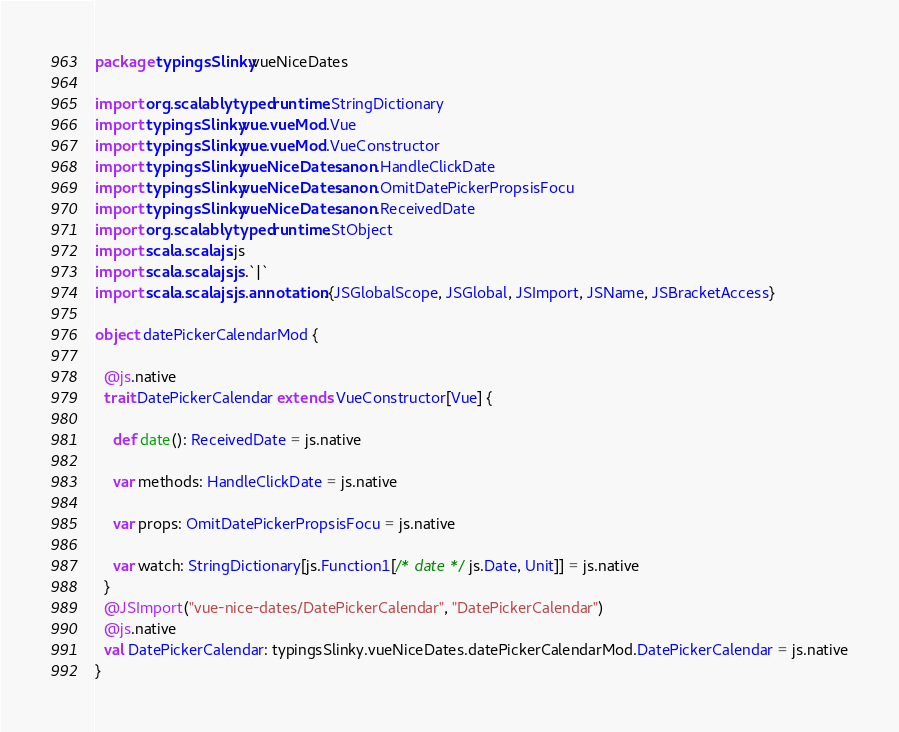Convert code to text. <code><loc_0><loc_0><loc_500><loc_500><_Scala_>package typingsSlinky.vueNiceDates

import org.scalablytyped.runtime.StringDictionary
import typingsSlinky.vue.vueMod.Vue
import typingsSlinky.vue.vueMod.VueConstructor
import typingsSlinky.vueNiceDates.anon.HandleClickDate
import typingsSlinky.vueNiceDates.anon.OmitDatePickerPropsisFocu
import typingsSlinky.vueNiceDates.anon.ReceivedDate
import org.scalablytyped.runtime.StObject
import scala.scalajs.js
import scala.scalajs.js.`|`
import scala.scalajs.js.annotation.{JSGlobalScope, JSGlobal, JSImport, JSName, JSBracketAccess}

object datePickerCalendarMod {
  
  @js.native
  trait DatePickerCalendar extends VueConstructor[Vue] {
    
    def date(): ReceivedDate = js.native
    
    var methods: HandleClickDate = js.native
    
    var props: OmitDatePickerPropsisFocu = js.native
    
    var watch: StringDictionary[js.Function1[/* date */ js.Date, Unit]] = js.native
  }
  @JSImport("vue-nice-dates/DatePickerCalendar", "DatePickerCalendar")
  @js.native
  val DatePickerCalendar: typingsSlinky.vueNiceDates.datePickerCalendarMod.DatePickerCalendar = js.native
}
</code> 